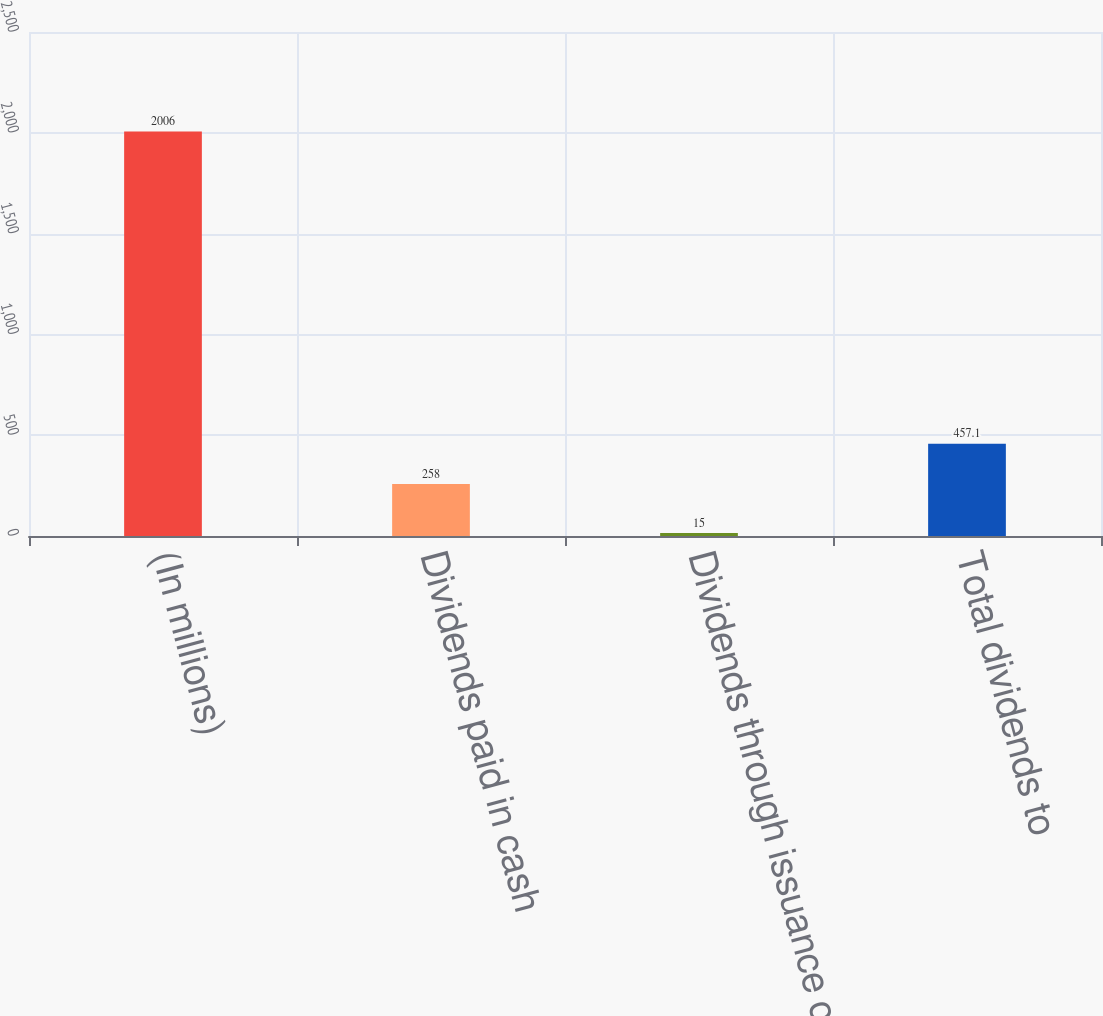Convert chart. <chart><loc_0><loc_0><loc_500><loc_500><bar_chart><fcel>(In millions)<fcel>Dividends paid in cash<fcel>Dividends through issuance of<fcel>Total dividends to<nl><fcel>2006<fcel>258<fcel>15<fcel>457.1<nl></chart> 